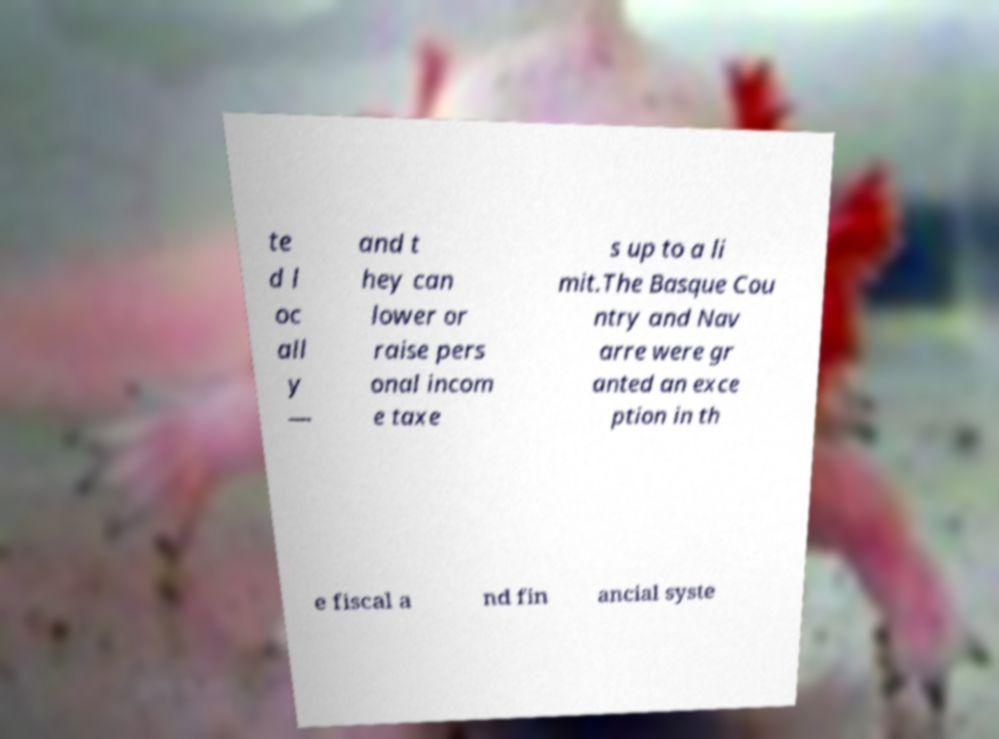I need the written content from this picture converted into text. Can you do that? te d l oc all y — and t hey can lower or raise pers onal incom e taxe s up to a li mit.The Basque Cou ntry and Nav arre were gr anted an exce ption in th e fiscal a nd fin ancial syste 